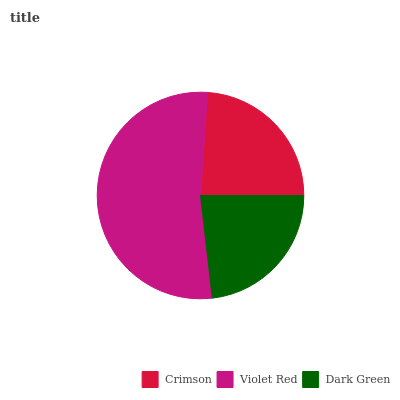Is Dark Green the minimum?
Answer yes or no. Yes. Is Violet Red the maximum?
Answer yes or no. Yes. Is Violet Red the minimum?
Answer yes or no. No. Is Dark Green the maximum?
Answer yes or no. No. Is Violet Red greater than Dark Green?
Answer yes or no. Yes. Is Dark Green less than Violet Red?
Answer yes or no. Yes. Is Dark Green greater than Violet Red?
Answer yes or no. No. Is Violet Red less than Dark Green?
Answer yes or no. No. Is Crimson the high median?
Answer yes or no. Yes. Is Crimson the low median?
Answer yes or no. Yes. Is Dark Green the high median?
Answer yes or no. No. Is Violet Red the low median?
Answer yes or no. No. 